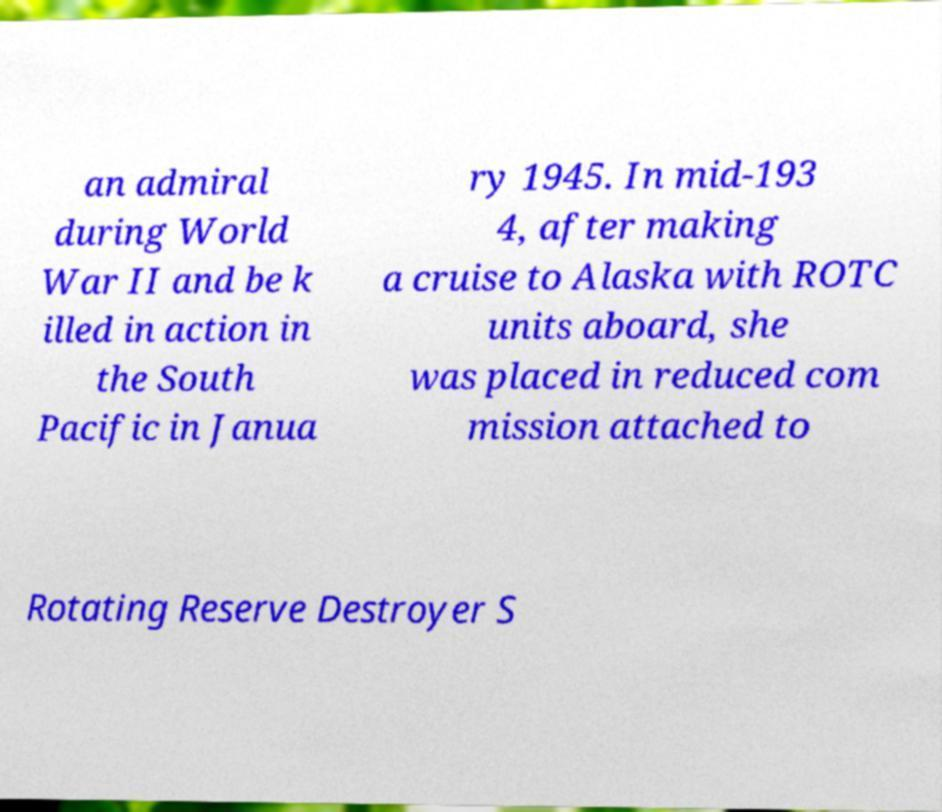Please identify and transcribe the text found in this image. an admiral during World War II and be k illed in action in the South Pacific in Janua ry 1945. In mid-193 4, after making a cruise to Alaska with ROTC units aboard, she was placed in reduced com mission attached to Rotating Reserve Destroyer S 